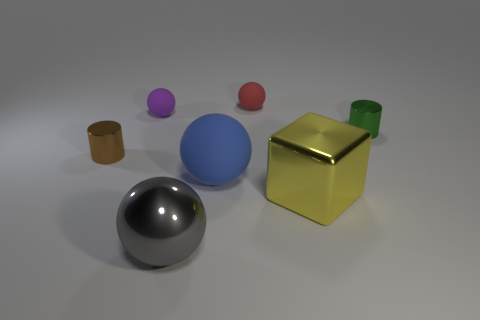Add 1 small purple shiny blocks. How many objects exist? 8 Subtract all cubes. How many objects are left? 6 Add 5 gray metal things. How many gray metal things are left? 6 Add 6 large cyan blocks. How many large cyan blocks exist? 6 Subtract 0 gray cylinders. How many objects are left? 7 Subtract all big gray metallic things. Subtract all tiny purple things. How many objects are left? 5 